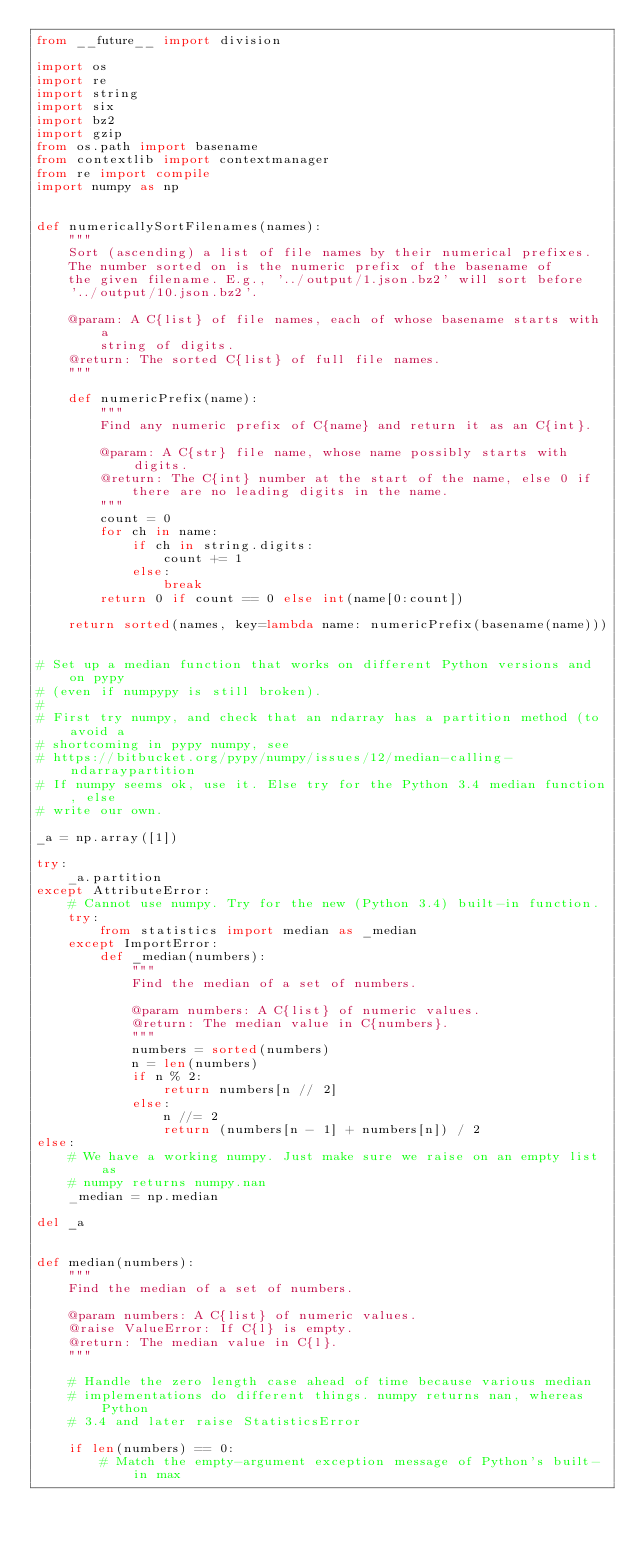Convert code to text. <code><loc_0><loc_0><loc_500><loc_500><_Python_>from __future__ import division

import os
import re
import string
import six
import bz2
import gzip
from os.path import basename
from contextlib import contextmanager
from re import compile
import numpy as np


def numericallySortFilenames(names):
    """
    Sort (ascending) a list of file names by their numerical prefixes.
    The number sorted on is the numeric prefix of the basename of
    the given filename. E.g., '../output/1.json.bz2' will sort before
    '../output/10.json.bz2'.

    @param: A C{list} of file names, each of whose basename starts with a
        string of digits.
    @return: The sorted C{list} of full file names.
    """

    def numericPrefix(name):
        """
        Find any numeric prefix of C{name} and return it as an C{int}.

        @param: A C{str} file name, whose name possibly starts with digits.
        @return: The C{int} number at the start of the name, else 0 if
            there are no leading digits in the name.
        """
        count = 0
        for ch in name:
            if ch in string.digits:
                count += 1
            else:
                break
        return 0 if count == 0 else int(name[0:count])

    return sorted(names, key=lambda name: numericPrefix(basename(name)))


# Set up a median function that works on different Python versions and on pypy
# (even if numpypy is still broken).
#
# First try numpy, and check that an ndarray has a partition method (to avoid a
# shortcoming in pypy numpy, see
# https://bitbucket.org/pypy/numpy/issues/12/median-calling-ndarraypartition
# If numpy seems ok, use it. Else try for the Python 3.4 median function, else
# write our own.

_a = np.array([1])

try:
    _a.partition
except AttributeError:
    # Cannot use numpy. Try for the new (Python 3.4) built-in function.
    try:
        from statistics import median as _median
    except ImportError:
        def _median(numbers):
            """
            Find the median of a set of numbers.

            @param numbers: A C{list} of numeric values.
            @return: The median value in C{numbers}.
            """
            numbers = sorted(numbers)
            n = len(numbers)
            if n % 2:
                return numbers[n // 2]
            else:
                n //= 2
                return (numbers[n - 1] + numbers[n]) / 2
else:
    # We have a working numpy. Just make sure we raise on an empty list as
    # numpy returns numpy.nan
    _median = np.median

del _a


def median(numbers):
    """
    Find the median of a set of numbers.

    @param numbers: A C{list} of numeric values.
    @raise ValueError: If C{l} is empty.
    @return: The median value in C{l}.
    """

    # Handle the zero length case ahead of time because various median
    # implementations do different things. numpy returns nan, whereas Python
    # 3.4 and later raise StatisticsError

    if len(numbers) == 0:
        # Match the empty-argument exception message of Python's built-in max</code> 